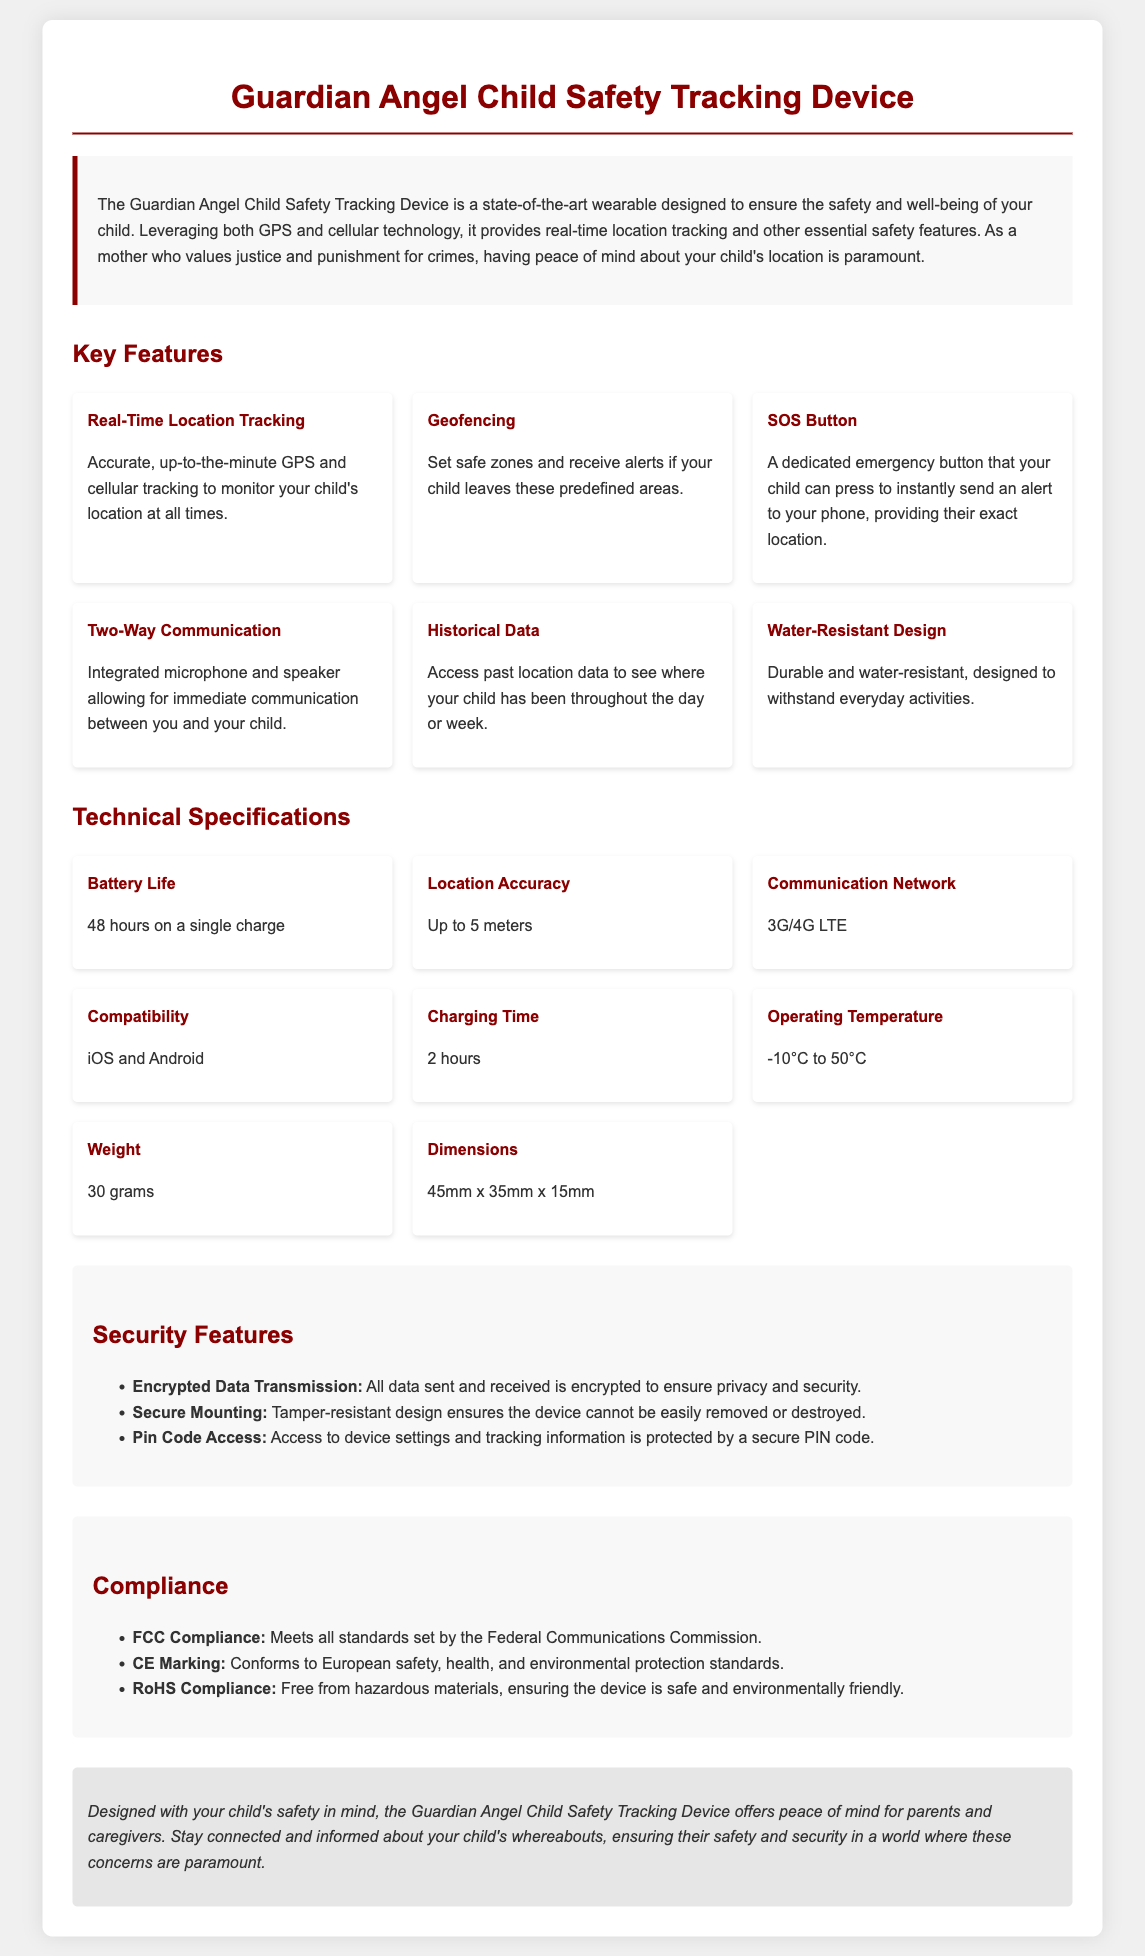what is the device's battery life? The battery life is specified in the technical specifications section as lasting for 48 hours on a single charge.
Answer: 48 hours what is the weight of the device? The weight is provided in the technical specifications section, which states it is 30 grams.
Answer: 30 grams what types of communication networks does the device support? This information is in the technical specifications, where it mentions support for 3G/4G LTE communication networks.
Answer: 3G/4G LTE what is the primary function of the SOS button? The product features point out that the SOS button sends an alert to the parent's phone, providing the child's exact location, indicating its emergency function.
Answer: Send an alert how does the device ensure data privacy and security? The document outlines that all data sent and received is encrypted, and access to device settings requires a secure PIN code, demonstrating its approach to data security.
Answer: Encrypted data transmission what is the operating temperature range for the device? The operating temperature range is provided in the technical specifications and is stated as -10°C to 50°C.
Answer: -10°C to 50°C what feature allows parents to receive alerts when their child leaves a safe area? The document indicates that the geofencing feature allows this type of alert based on predefined safe zones.
Answer: Geofencing which compliance standards does the device meet? This information is summarized in the compliance section, listing FCC compliance, CE marking, and RoHS compliance as the standards the device meets.
Answer: FCC, CE, RoHS how long does it take to fully charge the device? The charging time is included in the technical specifications, which states it takes 2 hours to fully charge.
Answer: 2 hours 